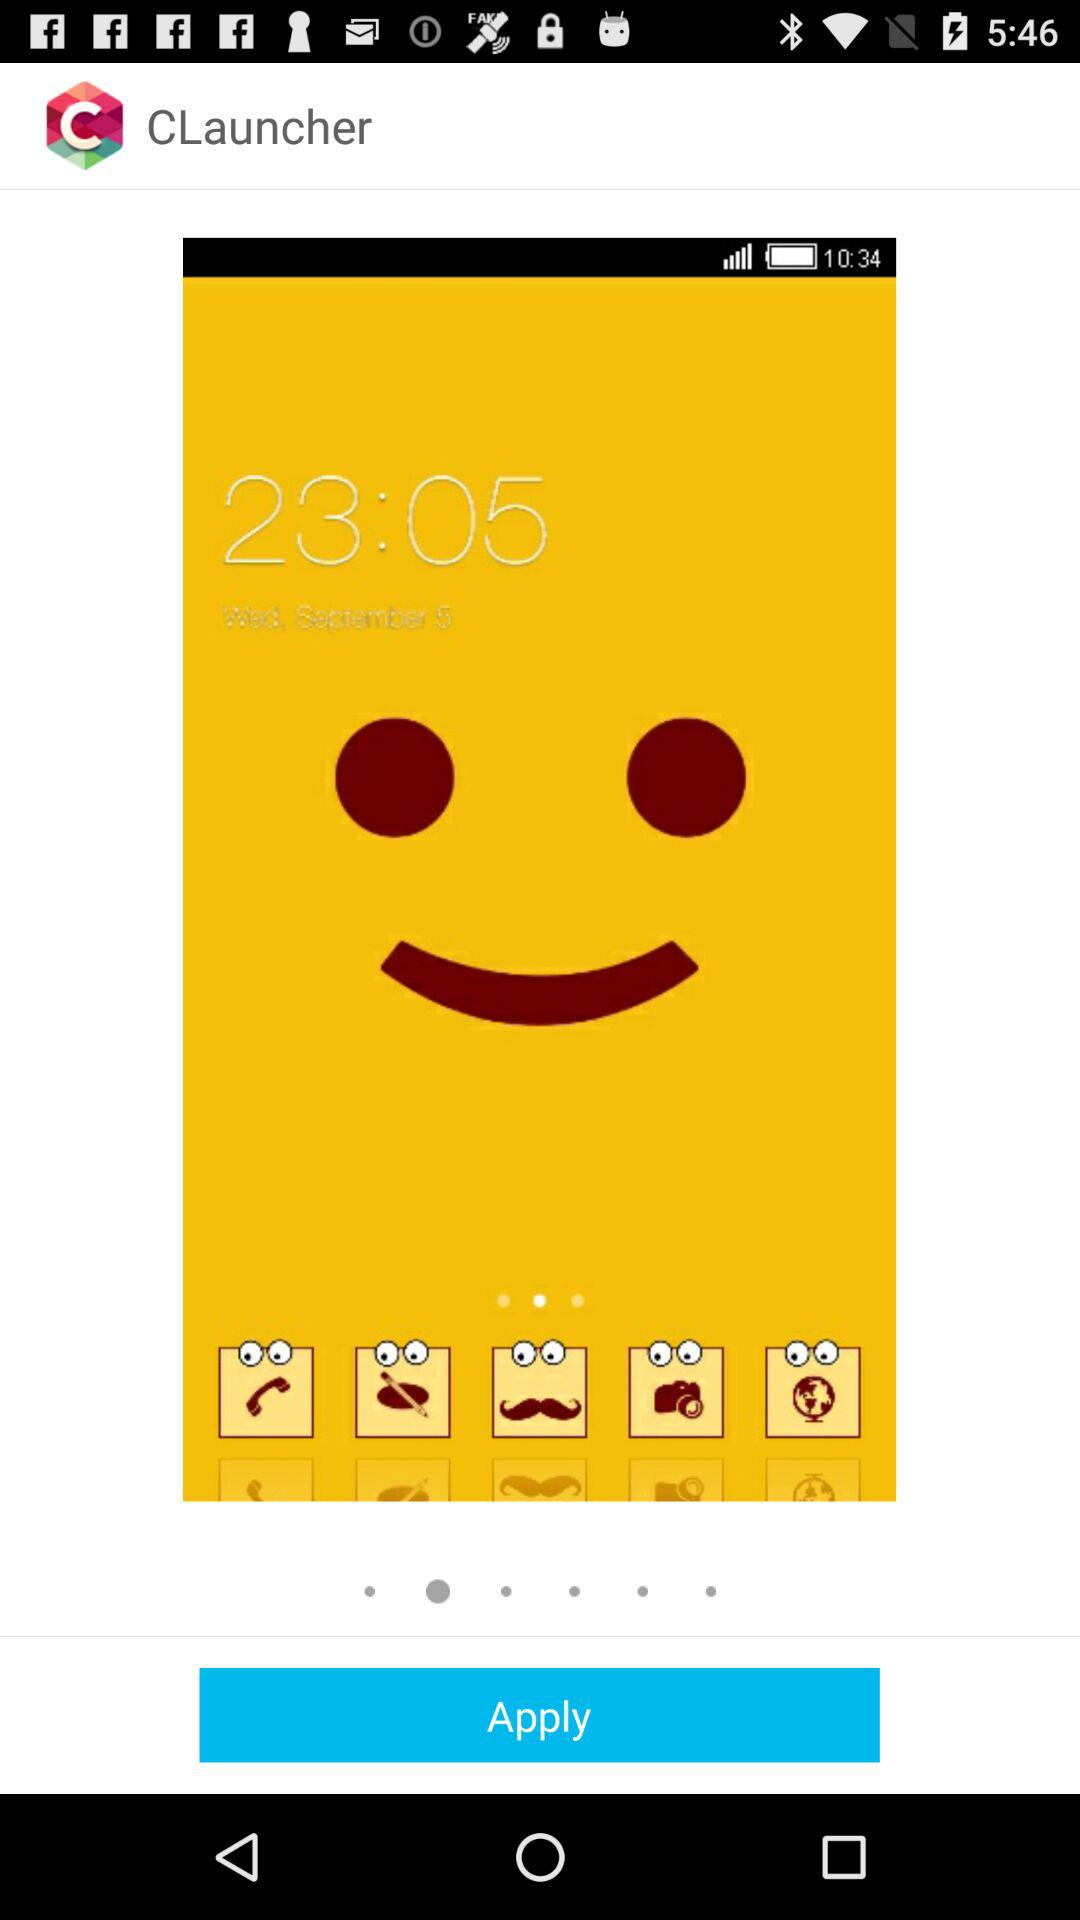What is the name of the application? The name of the application is "CLauncher". 